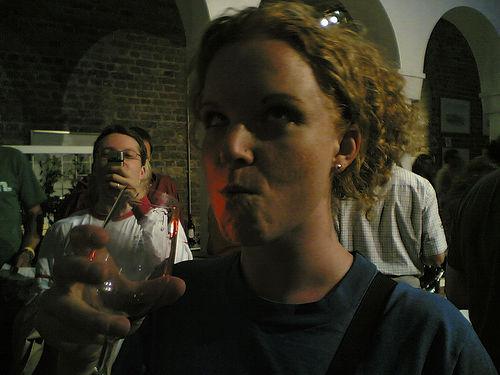What is in the woman's hand?
Give a very brief answer. Glass. Could this woman be telling a secret?
Short answer required. No. Is the girl wearing earrings?
Give a very brief answer. Yes. Is someone taking a picture?
Quick response, please. Yes. 